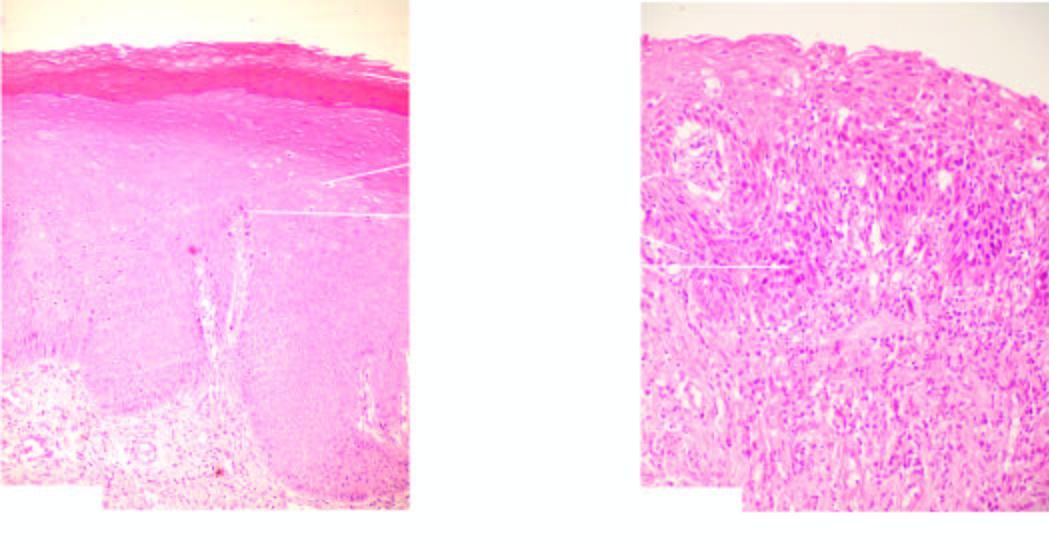do the individual cells in layers show features of cytologic atypia and mitosis?
Answer the question using a single word or phrase. Yes 